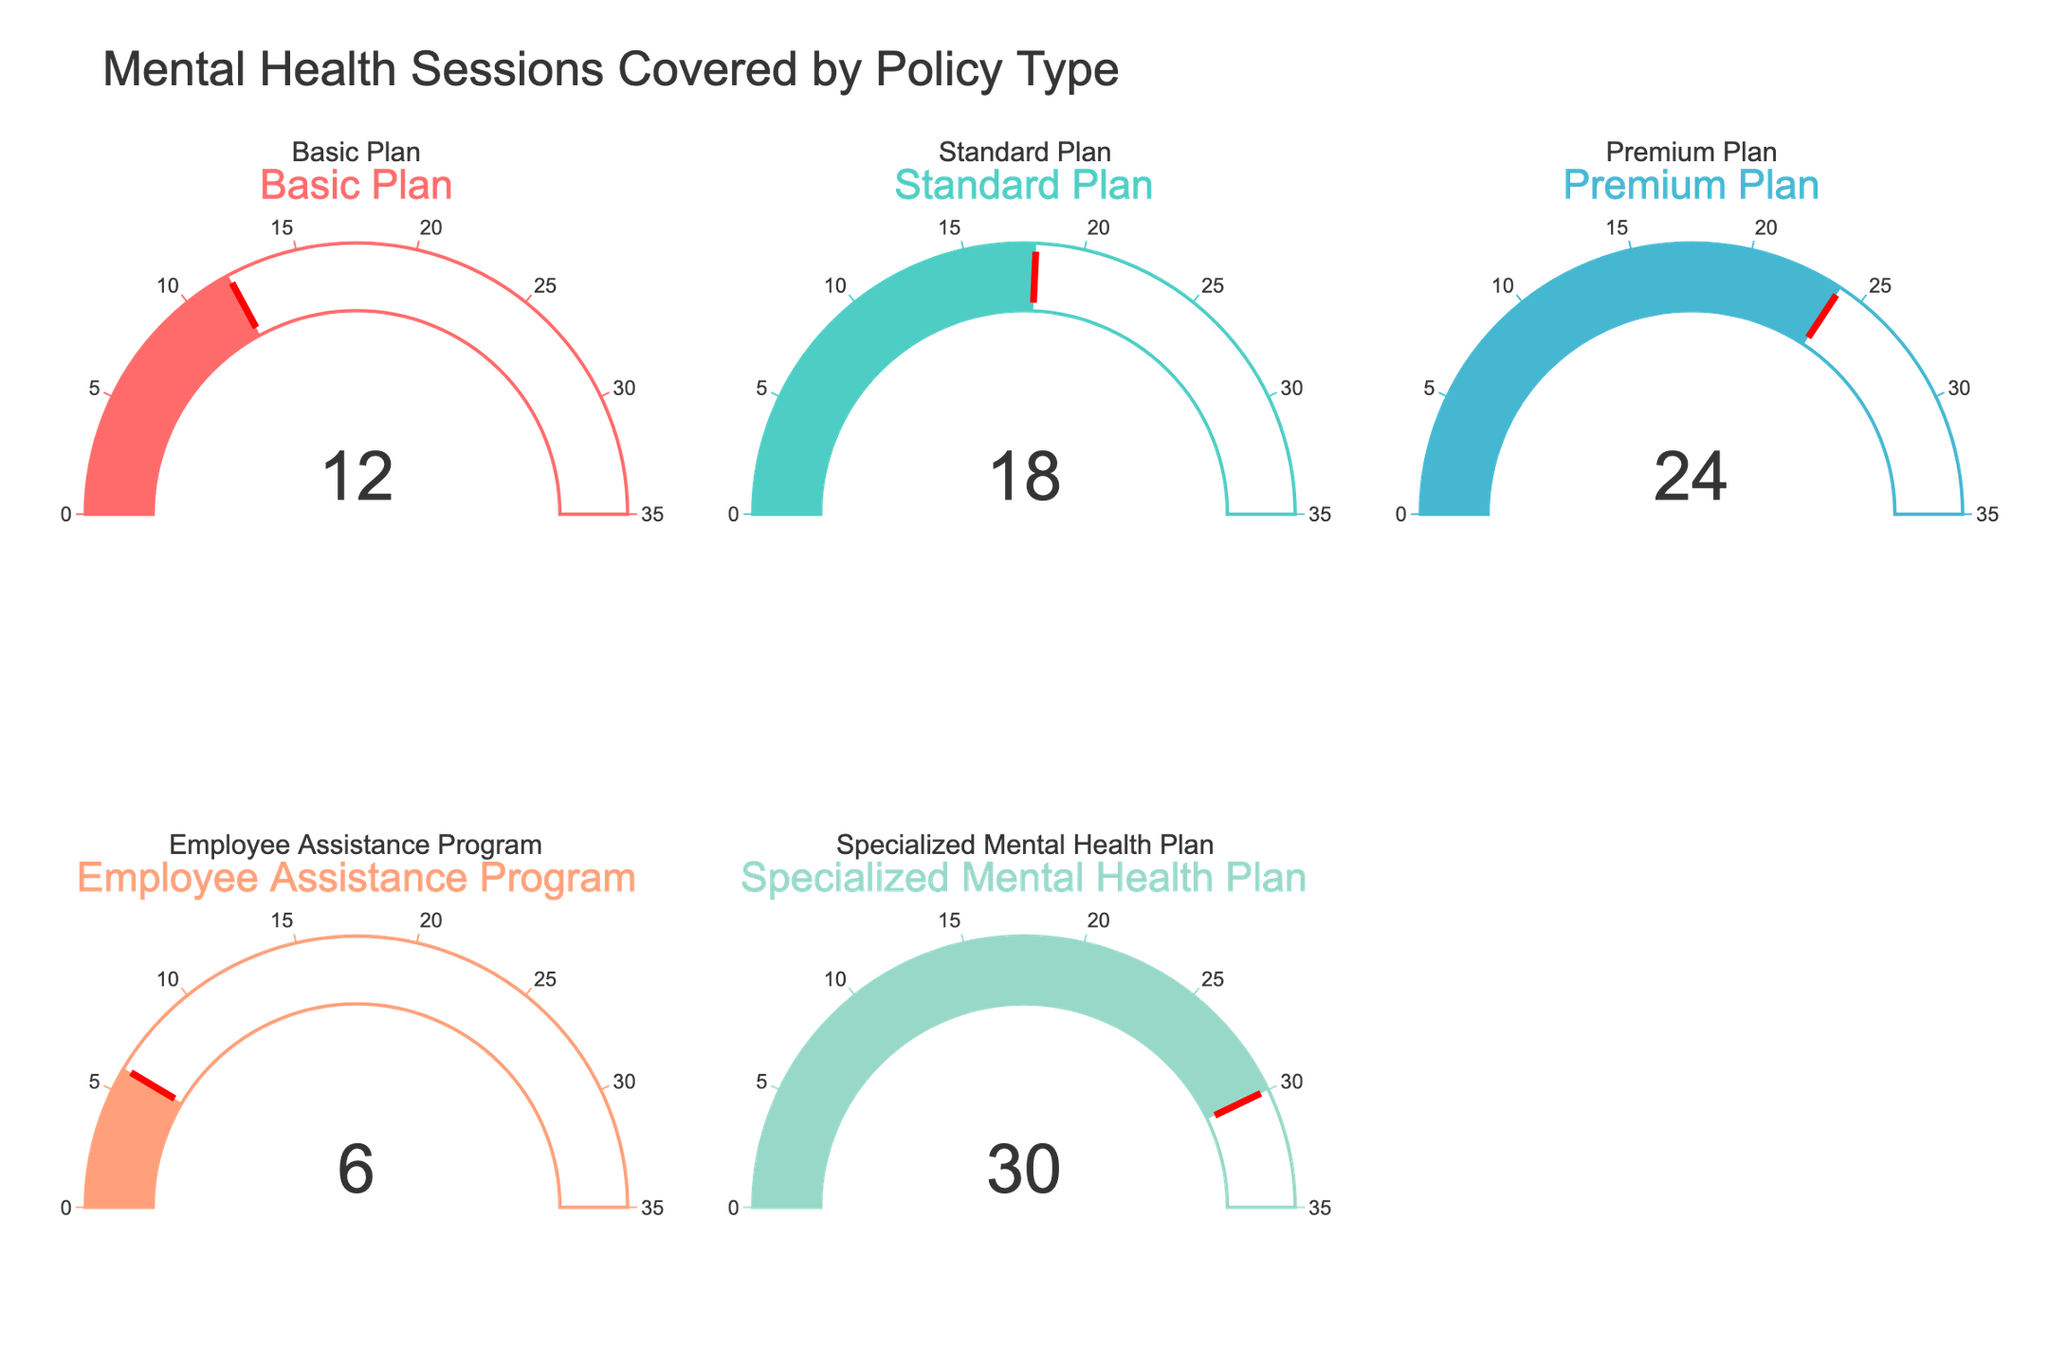What's the title of the figure? The title is displayed at the top of the figure in large font size, which reads "Mental Health Sessions Covered by Policy Type".
Answer: Mental Health Sessions Covered by Policy Type How many policy types are shown in the figure? Each gauge represents a different policy type, and counting all the unique titles, there are five policy types represented.
Answer: Five What is the highest number of mental health sessions covered by any policy type? Looking at all the gauges, the highest value indicated is 30, which corresponds to the Specialized Mental Health Plan.
Answer: 30 Which policy type covers the least number of mental health sessions? The gauge labeled "Employee Assistance Program" indicates the lowest value of 6 sessions.
Answer: Employee Assistance Program What is the difference in the number of sessions covered between the Premium Plan and the Standard Plan? The Premium Plan covers 24 sessions, and the Standard Plan covers 18 sessions. The difference is 24 - 18 = 6.
Answer: 6 What is the average number of sessions covered by the Basic Plan and the Employee Assistance Program? The Basic Plan covers 12 sessions, and the Employee Assistance Program covers 6 sessions. The average is (12 + 6)/2 = 9.
Answer: 9 How much more coverage does the Specialized Mental Health Plan provide compared to the Basic Plan? The Specialized Mental Health Plan covers 30 sessions, while the Basic Plan covers 12 sessions. The difference is 30 - 12 = 18 sessions more.
Answer: 18 Arrange the policy types in descending order of sessions coverage. By comparing the values on each gauge, the order from highest to lowest is Specialized Mental Health Plan (30), Premium Plan (24), Standard Plan (18), Basic Plan (12), and Employee Assistance Program (6).
Answer: Specialized Mental Health Plan, Premium Plan, Standard Plan, Basic Plan, Employee Assistance Program If the Basic Plan and the Standard Plan are combined into a new plan, how many sessions would it cover in total? Adding the number of sessions covered by the Basic Plan (12) and the Standard Plan (18) gives a total of 12 + 18 = 30 sessions.
Answer: 30 What is the median number of sessions covered across all policy types? The number of sessions covered across all policy types are 12, 18, 24, 6, and 30. Arranging these values in ascending order gives 6, 12, 18, 24, 30. The middle value (median) in this ordered list is 18.
Answer: 18 